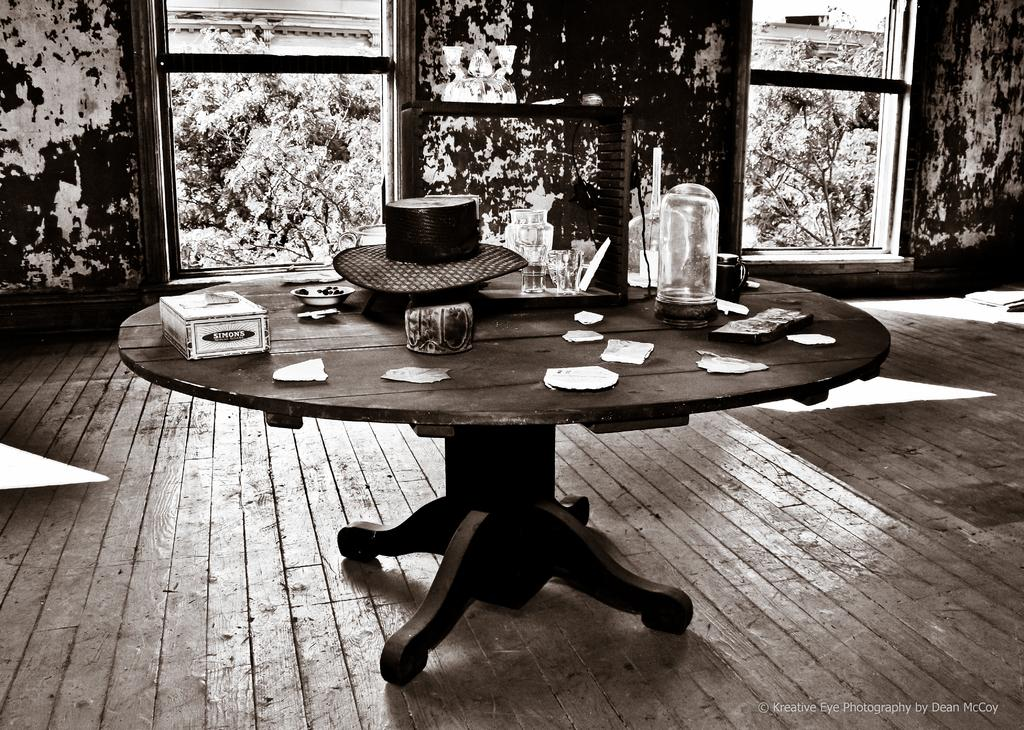What type of furniture is in the image? There is a table in the image. What is on the table? There are objects on the table, including tissues, glasses, and a hat. Can you describe the background of the image? There is a wall in the background of the image, and trees are visible. What type of pie is being served by the fairies in the image? There are no fairies or pies present in the image. How many feet can be seen in the image? There is no reference to feet or footwear in the image. 